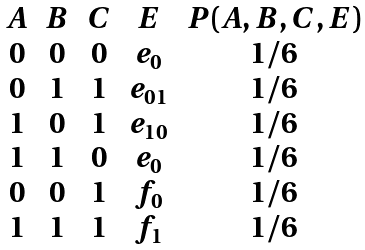Convert formula to latex. <formula><loc_0><loc_0><loc_500><loc_500>\begin{array} { c c c c c } A & B & C & E & P ( A , B , C , E ) \\ 0 & 0 & 0 & e _ { 0 } & 1 / 6 \\ 0 & 1 & 1 & e _ { 0 1 } & 1 / 6 \\ 1 & 0 & 1 & e _ { 1 0 } & 1 / 6 \\ 1 & 1 & 0 & e _ { 0 } & 1 / 6 \\ 0 & 0 & 1 & f _ { 0 } & 1 / 6 \\ 1 & 1 & 1 & f _ { 1 } & 1 / 6 \\ \end{array}</formula> 